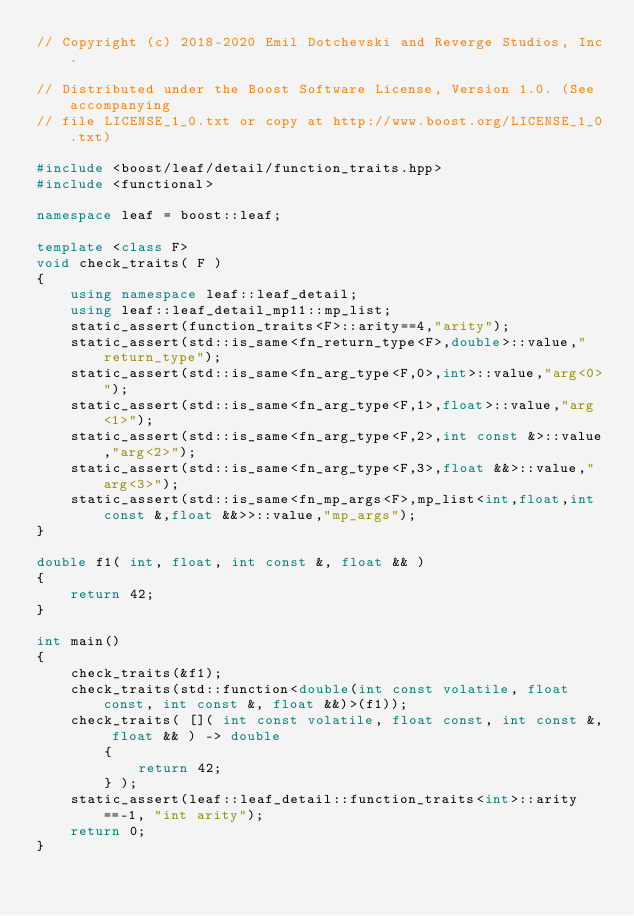Convert code to text. <code><loc_0><loc_0><loc_500><loc_500><_C++_>// Copyright (c) 2018-2020 Emil Dotchevski and Reverge Studios, Inc.

// Distributed under the Boost Software License, Version 1.0. (See accompanying
// file LICENSE_1_0.txt or copy at http://www.boost.org/LICENSE_1_0.txt)

#include <boost/leaf/detail/function_traits.hpp>
#include <functional>

namespace leaf = boost::leaf;

template <class F>
void check_traits( F )
{
    using namespace leaf::leaf_detail;
    using leaf::leaf_detail_mp11::mp_list;
    static_assert(function_traits<F>::arity==4,"arity");
    static_assert(std::is_same<fn_return_type<F>,double>::value,"return_type");
    static_assert(std::is_same<fn_arg_type<F,0>,int>::value,"arg<0>");
    static_assert(std::is_same<fn_arg_type<F,1>,float>::value,"arg<1>");
    static_assert(std::is_same<fn_arg_type<F,2>,int const &>::value,"arg<2>");
    static_assert(std::is_same<fn_arg_type<F,3>,float &&>::value,"arg<3>");
    static_assert(std::is_same<fn_mp_args<F>,mp_list<int,float,int const &,float &&>>::value,"mp_args");
}

double f1( int, float, int const &, float && )
{
    return 42;
}

int main()
{
    check_traits(&f1);
    check_traits(std::function<double(int const volatile, float const, int const &, float &&)>(f1));
    check_traits( []( int const volatile, float const, int const &, float && ) -> double
        {
            return 42;
        } );
    static_assert(leaf::leaf_detail::function_traits<int>::arity==-1, "int arity");
    return 0;
}
</code> 